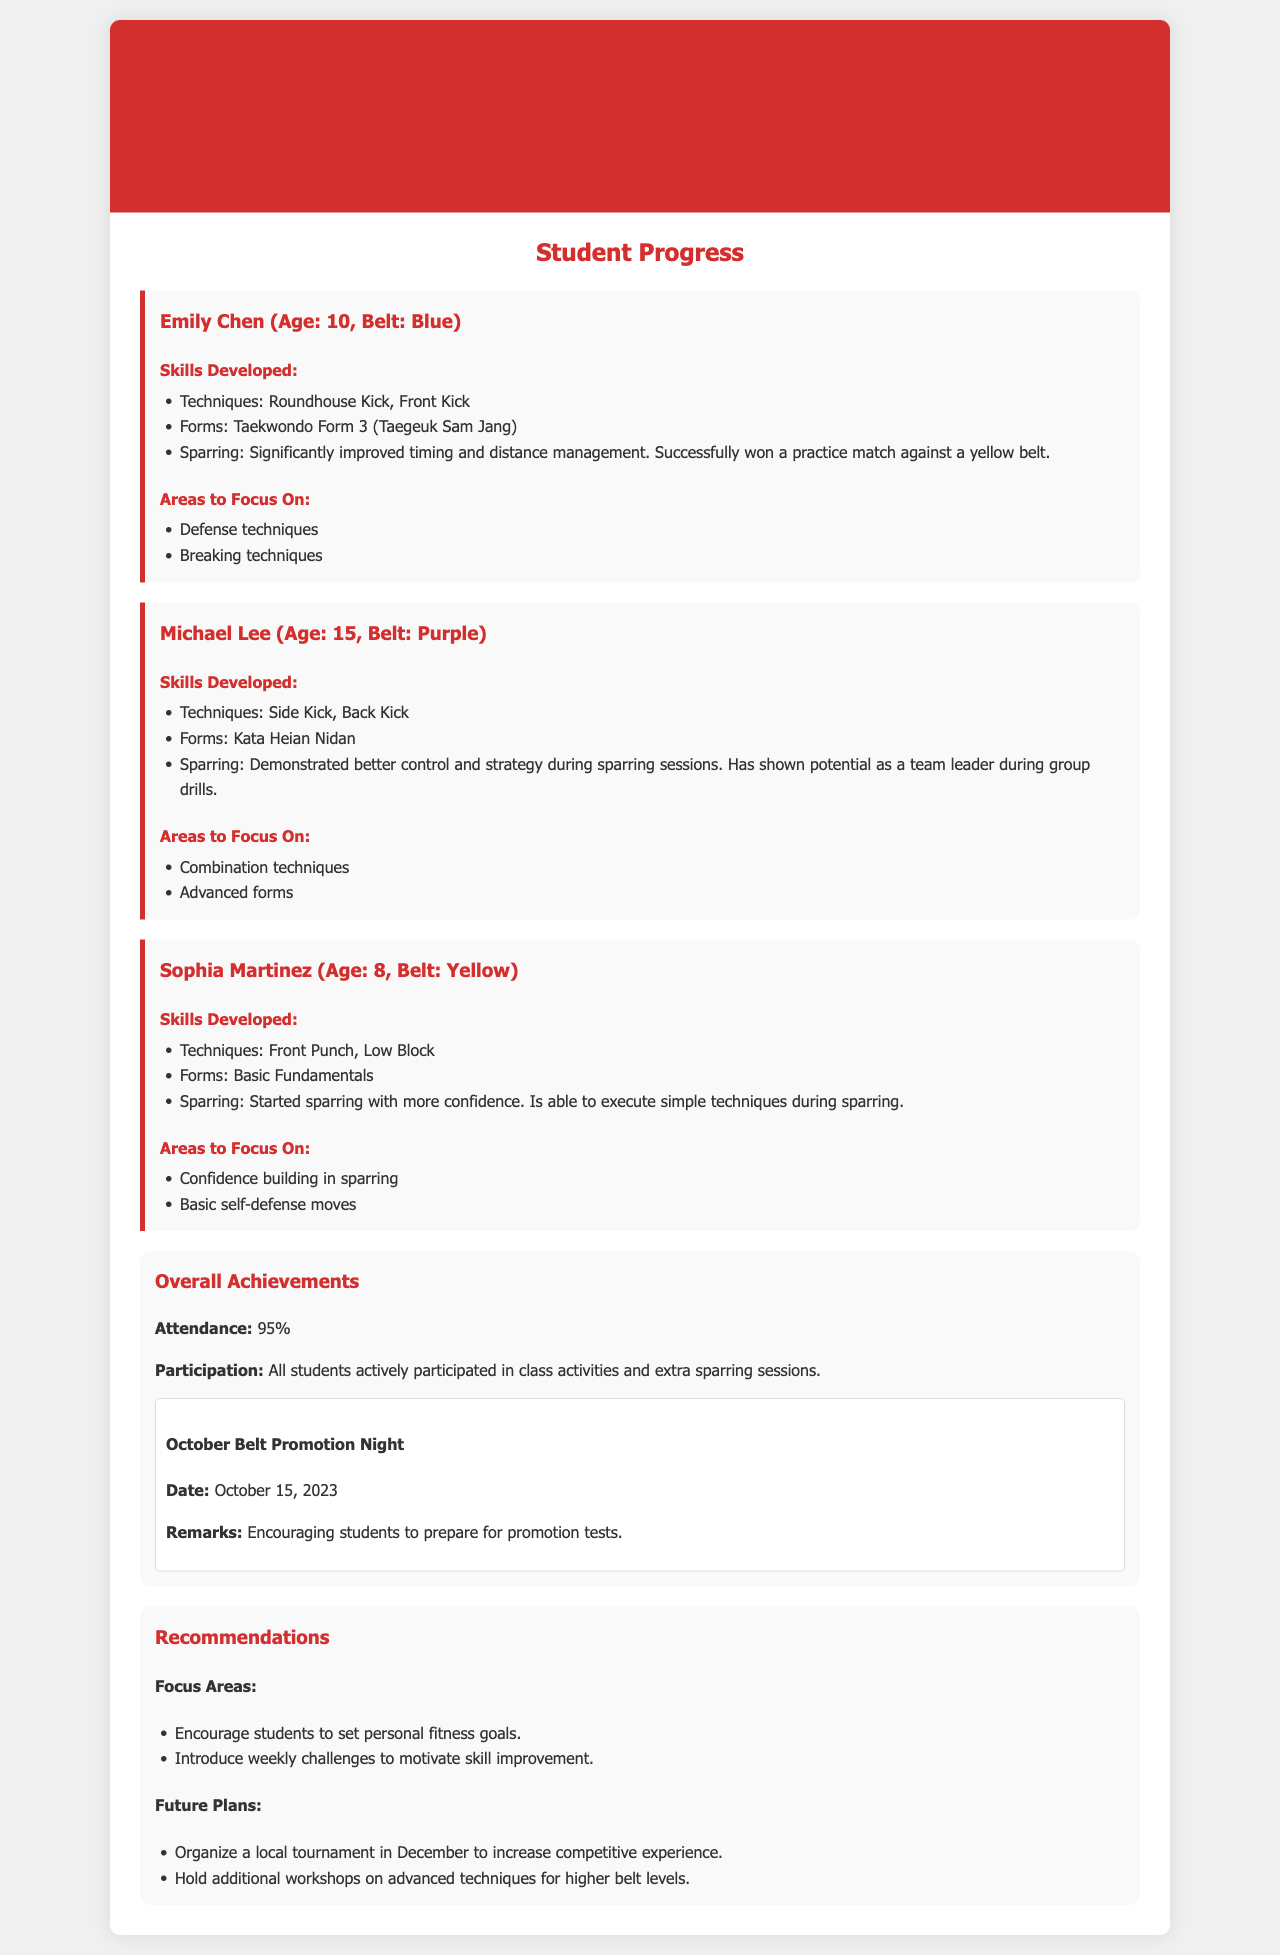What is the title of the report? The title of the report is mentioned at the top of the document in a prominent position.
Answer: Monthly Progress Report - October 2023 Who is the first student mentioned in the report? The first student mentioned in the report is the one highlighted in the first section of the student progress.
Answer: Emily Chen What belt rank does Michael Lee hold? Michael Lee's rank is indicated in his section where the student's details are provided.
Answer: Purple What is the attendance percentage reported for the month? The attendance percentage is listed in the overall achievements section of the report.
Answer: 95% What technique significantly improved for Emily Chen during sparring? This information is found in the skills developed section for Emily Chen, detailing her sparring progress.
Answer: Timing and distance management What are the recommended focus areas for the students? This information can be found under the recommendations section, summarizing key areas to work on.
Answer: Personal fitness goals What event took place on October 15, 2023? The event is clearly stated in the overall achievements section with a specific date.
Answer: October Belt Promotion Night Which student is encouraged to build confidence in sparring? This detail relates to one of the focus areas mentioned for a specific student during skill development discussions.
Answer: Sophia Martinez What future plan is suggested for December? The future plans are outlined in the recommendations section, specifying an upcoming activity.
Answer: Local tournament 